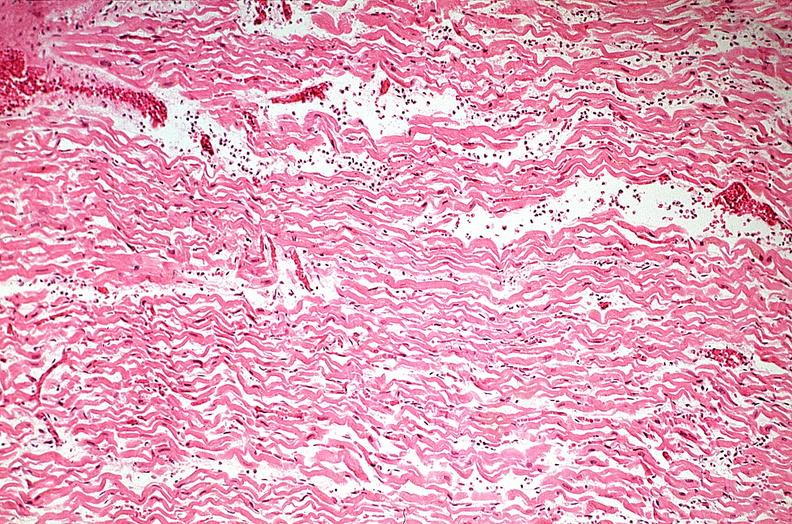where is this from?
Answer the question using a single word or phrase. Heart 